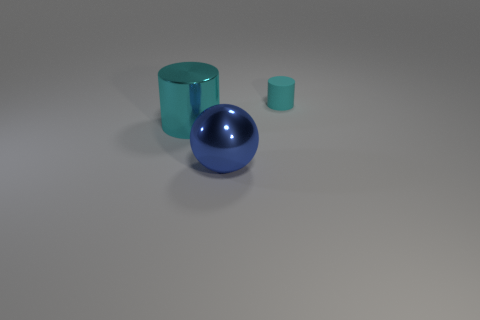How many other shiny balls have the same size as the sphere?
Ensure brevity in your answer.  0. Do the cyan object on the left side of the small cyan matte cylinder and the matte cylinder that is on the right side of the blue thing have the same size?
Your response must be concise. No. There is a cyan cylinder to the left of the small matte cylinder; what size is it?
Provide a succinct answer. Large. There is a cyan rubber cylinder that is behind the cylinder that is in front of the small cyan matte object; what size is it?
Make the answer very short. Small. What is the material of the blue ball that is the same size as the shiny cylinder?
Your answer should be very brief. Metal. Are there any metal spheres right of the big blue shiny ball?
Provide a succinct answer. No. Are there the same number of blue spheres behind the tiny cyan rubber cylinder and big green rubber cylinders?
Make the answer very short. Yes. What shape is the blue metal thing that is the same size as the cyan metal cylinder?
Offer a terse response. Sphere. What is the big cyan cylinder made of?
Give a very brief answer. Metal. There is a object that is right of the large cyan metal object and behind the blue thing; what color is it?
Offer a very short reply. Cyan. 